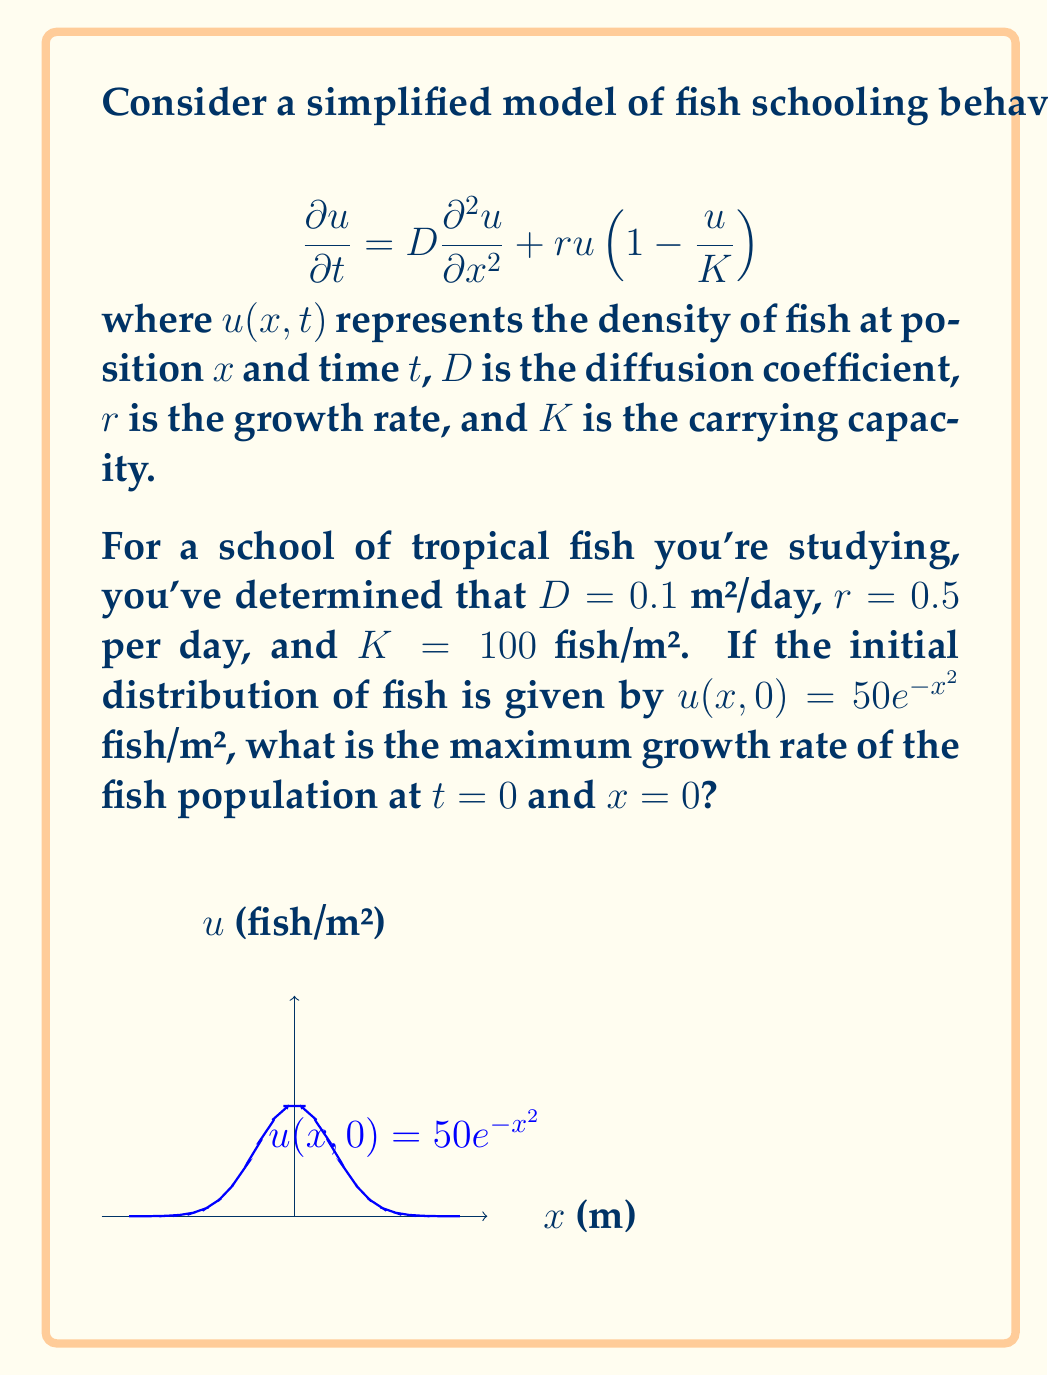Can you solve this math problem? To solve this problem, we need to follow these steps:

1) The growth rate of the fish population is given by the right-hand side of the Fisher-Kolmogorov equation:

   $$\frac{\partial u}{\partial t} = D\frac{\partial^2 u}{\partial x^2} + ru(1-\frac{u}{K})$$

2) At $t=0$, we need to evaluate both terms on the right-hand side:

   a) For the diffusion term $D\frac{\partial^2 u}{\partial x^2}$:
      First, we calculate $\frac{\partial u}{\partial x} = 50e^{-x^2}(-2x)$
      Then, $\frac{\partial^2 u}{\partial x^2} = 50e^{-x^2}(-2+4x^2)$
      At $x=0$, this becomes $50(-2) = -100$
      So, $D\frac{\partial^2 u}{\partial x^2} = 0.1 \times (-100) = -10$ fish/m²/day

   b) For the logistic growth term $ru(1-\frac{u}{K})$:
      At $x=0$, $u(0,0) = 50$ fish/m²
      So, $ru(1-\frac{u}{K}) = 0.5 \times 50 \times (1-\frac{50}{100}) = 12.5$ fish/m²/day

3) The total growth rate is the sum of these two terms:
   $-10 + 12.5 = 2.5$ fish/m²/day

Therefore, the maximum growth rate of the fish population at $t=0$ and $x=0$ is 2.5 fish/m²/day.
Answer: 2.5 fish/m²/day 